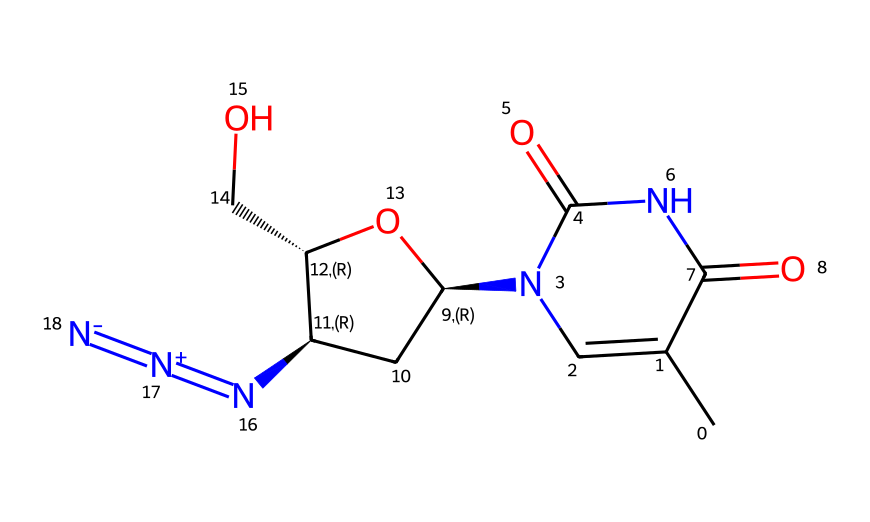What is the name of this chemical? The SMILES representation corresponds to azidothymidine, which is a derivative of thymidine used in HIV treatment.
Answer: azidothymidine How many nitrogen atoms are present in this chemical? By analyzing the structure implied by the SMILES, there are three nitrogen atoms (from the azide group and two in the purine-like structure).
Answer: three What functional group is indicated by the N=[N+]=[N-] portion of the molecule? The N=[N+]=[N-] portion represents an azide functional group, which consists of a linear arrangement of three nitrogen atoms with specific charge distribution.
Answer: azide What type of bond connects the azide group to the rest of the molecule? In the representation, the azide group is connected to the rest of the molecule via a single covalent bond, as indicated by the adjacent atoms in the structure.
Answer: single bond Identify the main role of azidothymidine in HIV treatment. Azidothymidine functions primarily as a nucleoside reverse transcriptase inhibitor, impeding viral replication by mimicking natural nucleotides.
Answer: nucleoside reverse transcriptase inhibitor How does steric hindrance affect the function of azidothymidine? The bulky azide group can induce steric hindrance, which may affect the enzyme interactions, leading to selective inhibition against HIV reverse transcriptase.
Answer: steric hindrance What is the stereochemistry of the chiral centers in azidothymidine? There are two chiral centers defined in the structure by specific stereochemical annotations in the SMILES, indicating distinct R or S configurations at both centers.
Answer: chiral centers 